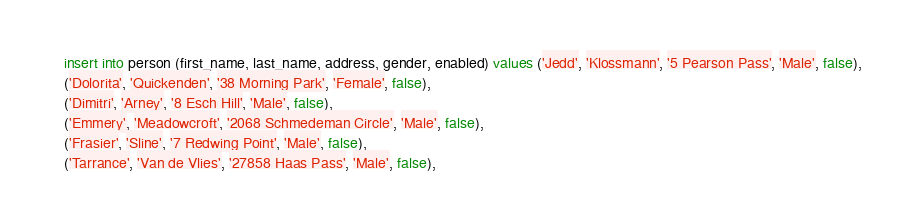Convert code to text. <code><loc_0><loc_0><loc_500><loc_500><_SQL_>insert into person (first_name, last_name, address, gender, enabled) values ('Jedd', 'Klossmann', '5 Pearson Pass', 'Male', false),
('Dolorita', 'Quickenden', '38 Morning Park', 'Female', false),
('Dimitri', 'Arney', '8 Esch Hill', 'Male', false),
('Emmery', 'Meadowcroft', '2068 Schmedeman Circle', 'Male', false),
('Frasier', 'Sline', '7 Redwing Point', 'Male', false),
('Tarrance', 'Van de Vlies', '27858 Haas Pass', 'Male', false),</code> 